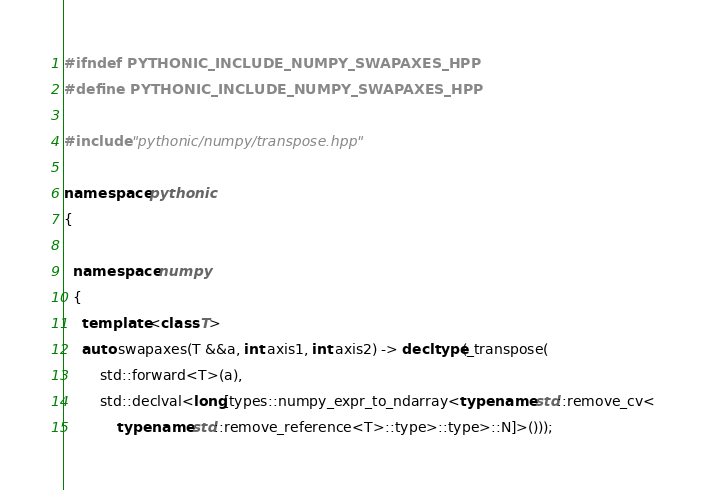<code> <loc_0><loc_0><loc_500><loc_500><_C++_>#ifndef PYTHONIC_INCLUDE_NUMPY_SWAPAXES_HPP
#define PYTHONIC_INCLUDE_NUMPY_SWAPAXES_HPP

#include "pythonic/numpy/transpose.hpp"

namespace pythonic
{

  namespace numpy
  {
    template <class T>
    auto swapaxes(T &&a, int axis1, int axis2) -> decltype(_transpose(
        std::forward<T>(a),
        std::declval<long[types::numpy_expr_to_ndarray<typename std::remove_cv<
            typename std::remove_reference<T>::type>::type>::N]>()));
</code> 